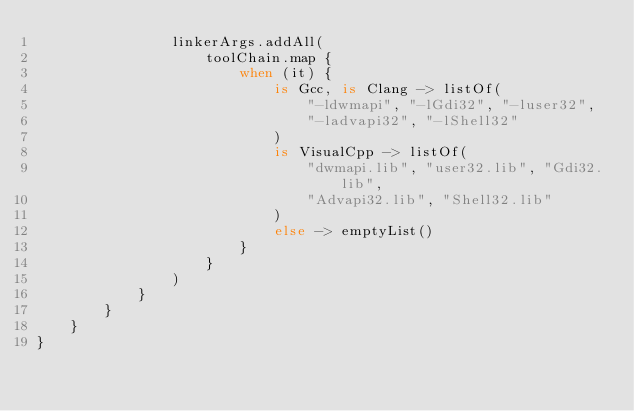<code> <loc_0><loc_0><loc_500><loc_500><_Kotlin_>                linkerArgs.addAll(
                    toolChain.map {
                        when (it) {
                            is Gcc, is Clang -> listOf(
                                "-ldwmapi", "-lGdi32", "-luser32",
                                "-ladvapi32", "-lShell32"
                            )
                            is VisualCpp -> listOf(
                                "dwmapi.lib", "user32.lib", "Gdi32.lib",
                                "Advapi32.lib", "Shell32.lib"
                            )
                            else -> emptyList()
                        }
                    }
                )
            }
        }
    }
}
</code> 